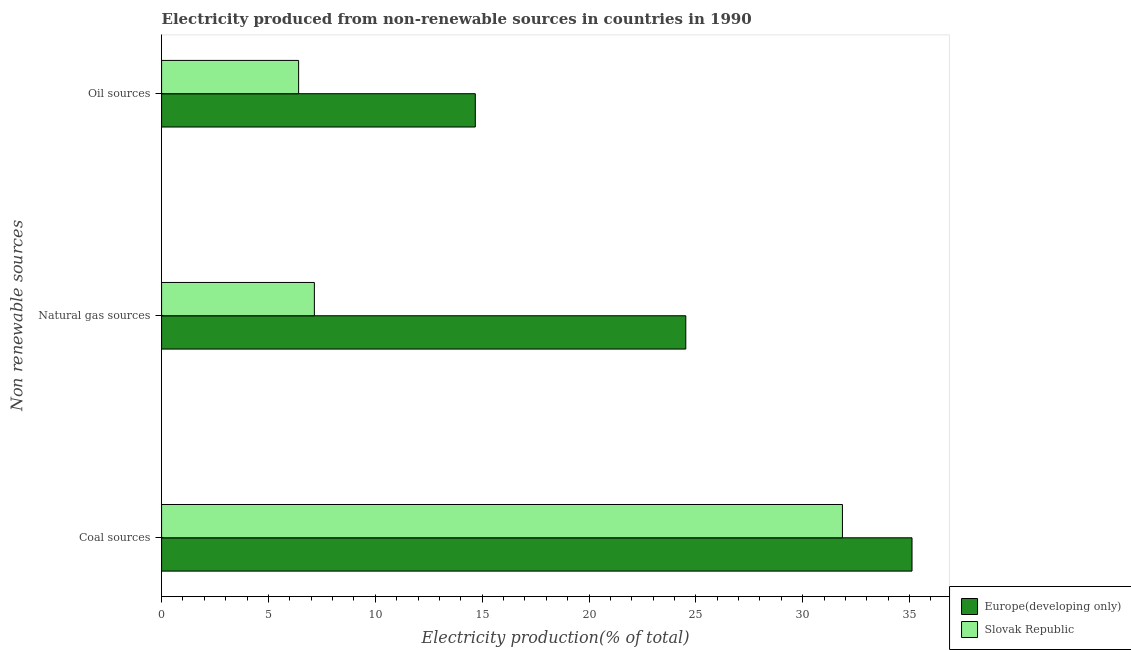How many groups of bars are there?
Offer a very short reply. 3. Are the number of bars per tick equal to the number of legend labels?
Your answer should be very brief. Yes. How many bars are there on the 2nd tick from the top?
Provide a short and direct response. 2. How many bars are there on the 3rd tick from the bottom?
Offer a very short reply. 2. What is the label of the 1st group of bars from the top?
Your response must be concise. Oil sources. What is the percentage of electricity produced by coal in Europe(developing only)?
Your answer should be very brief. 35.11. Across all countries, what is the maximum percentage of electricity produced by natural gas?
Ensure brevity in your answer.  24.53. Across all countries, what is the minimum percentage of electricity produced by coal?
Give a very brief answer. 31.86. In which country was the percentage of electricity produced by natural gas maximum?
Your answer should be compact. Europe(developing only). In which country was the percentage of electricity produced by oil sources minimum?
Provide a short and direct response. Slovak Republic. What is the total percentage of electricity produced by oil sources in the graph?
Ensure brevity in your answer.  21.09. What is the difference between the percentage of electricity produced by natural gas in Europe(developing only) and that in Slovak Republic?
Offer a terse response. 17.38. What is the difference between the percentage of electricity produced by oil sources in Slovak Republic and the percentage of electricity produced by coal in Europe(developing only)?
Your response must be concise. -28.7. What is the average percentage of electricity produced by oil sources per country?
Make the answer very short. 10.55. What is the difference between the percentage of electricity produced by oil sources and percentage of electricity produced by coal in Slovak Republic?
Offer a very short reply. -25.45. What is the ratio of the percentage of electricity produced by oil sources in Europe(developing only) to that in Slovak Republic?
Your response must be concise. 2.29. Is the percentage of electricity produced by natural gas in Slovak Republic less than that in Europe(developing only)?
Offer a very short reply. Yes. Is the difference between the percentage of electricity produced by coal in Europe(developing only) and Slovak Republic greater than the difference between the percentage of electricity produced by natural gas in Europe(developing only) and Slovak Republic?
Ensure brevity in your answer.  No. What is the difference between the highest and the second highest percentage of electricity produced by natural gas?
Make the answer very short. 17.38. What is the difference between the highest and the lowest percentage of electricity produced by coal?
Give a very brief answer. 3.26. In how many countries, is the percentage of electricity produced by coal greater than the average percentage of electricity produced by coal taken over all countries?
Ensure brevity in your answer.  1. What does the 2nd bar from the top in Coal sources represents?
Offer a terse response. Europe(developing only). What does the 1st bar from the bottom in Natural gas sources represents?
Keep it short and to the point. Europe(developing only). Is it the case that in every country, the sum of the percentage of electricity produced by coal and percentage of electricity produced by natural gas is greater than the percentage of electricity produced by oil sources?
Your answer should be very brief. Yes. Are all the bars in the graph horizontal?
Give a very brief answer. Yes. What is the difference between two consecutive major ticks on the X-axis?
Your answer should be very brief. 5. Are the values on the major ticks of X-axis written in scientific E-notation?
Your answer should be compact. No. Does the graph contain any zero values?
Provide a succinct answer. No. Does the graph contain grids?
Provide a short and direct response. No. Where does the legend appear in the graph?
Offer a terse response. Bottom right. How many legend labels are there?
Offer a terse response. 2. What is the title of the graph?
Give a very brief answer. Electricity produced from non-renewable sources in countries in 1990. Does "Andorra" appear as one of the legend labels in the graph?
Keep it short and to the point. No. What is the label or title of the Y-axis?
Your response must be concise. Non renewable sources. What is the Electricity production(% of total) in Europe(developing only) in Coal sources?
Offer a terse response. 35.11. What is the Electricity production(% of total) of Slovak Republic in Coal sources?
Provide a short and direct response. 31.86. What is the Electricity production(% of total) in Europe(developing only) in Natural gas sources?
Offer a very short reply. 24.53. What is the Electricity production(% of total) of Slovak Republic in Natural gas sources?
Give a very brief answer. 7.15. What is the Electricity production(% of total) in Europe(developing only) in Oil sources?
Ensure brevity in your answer.  14.68. What is the Electricity production(% of total) of Slovak Republic in Oil sources?
Provide a short and direct response. 6.41. Across all Non renewable sources, what is the maximum Electricity production(% of total) in Europe(developing only)?
Keep it short and to the point. 35.11. Across all Non renewable sources, what is the maximum Electricity production(% of total) in Slovak Republic?
Give a very brief answer. 31.86. Across all Non renewable sources, what is the minimum Electricity production(% of total) of Europe(developing only)?
Provide a short and direct response. 14.68. Across all Non renewable sources, what is the minimum Electricity production(% of total) in Slovak Republic?
Give a very brief answer. 6.41. What is the total Electricity production(% of total) of Europe(developing only) in the graph?
Your answer should be very brief. 74.32. What is the total Electricity production(% of total) of Slovak Republic in the graph?
Your answer should be compact. 45.42. What is the difference between the Electricity production(% of total) of Europe(developing only) in Coal sources and that in Natural gas sources?
Provide a succinct answer. 10.59. What is the difference between the Electricity production(% of total) in Slovak Republic in Coal sources and that in Natural gas sources?
Give a very brief answer. 24.71. What is the difference between the Electricity production(% of total) in Europe(developing only) in Coal sources and that in Oil sources?
Offer a terse response. 20.43. What is the difference between the Electricity production(% of total) in Slovak Republic in Coal sources and that in Oil sources?
Provide a succinct answer. 25.45. What is the difference between the Electricity production(% of total) in Europe(developing only) in Natural gas sources and that in Oil sources?
Your answer should be compact. 9.85. What is the difference between the Electricity production(% of total) in Slovak Republic in Natural gas sources and that in Oil sources?
Provide a short and direct response. 0.74. What is the difference between the Electricity production(% of total) in Europe(developing only) in Coal sources and the Electricity production(% of total) in Slovak Republic in Natural gas sources?
Your answer should be very brief. 27.96. What is the difference between the Electricity production(% of total) of Europe(developing only) in Coal sources and the Electricity production(% of total) of Slovak Republic in Oil sources?
Your answer should be very brief. 28.7. What is the difference between the Electricity production(% of total) in Europe(developing only) in Natural gas sources and the Electricity production(% of total) in Slovak Republic in Oil sources?
Give a very brief answer. 18.12. What is the average Electricity production(% of total) of Europe(developing only) per Non renewable sources?
Offer a terse response. 24.77. What is the average Electricity production(% of total) in Slovak Republic per Non renewable sources?
Provide a succinct answer. 15.14. What is the difference between the Electricity production(% of total) in Europe(developing only) and Electricity production(% of total) in Slovak Republic in Coal sources?
Keep it short and to the point. 3.26. What is the difference between the Electricity production(% of total) of Europe(developing only) and Electricity production(% of total) of Slovak Republic in Natural gas sources?
Provide a succinct answer. 17.38. What is the difference between the Electricity production(% of total) in Europe(developing only) and Electricity production(% of total) in Slovak Republic in Oil sources?
Your response must be concise. 8.27. What is the ratio of the Electricity production(% of total) of Europe(developing only) in Coal sources to that in Natural gas sources?
Make the answer very short. 1.43. What is the ratio of the Electricity production(% of total) in Slovak Republic in Coal sources to that in Natural gas sources?
Your answer should be compact. 4.46. What is the ratio of the Electricity production(% of total) of Europe(developing only) in Coal sources to that in Oil sources?
Your answer should be compact. 2.39. What is the ratio of the Electricity production(% of total) in Slovak Republic in Coal sources to that in Oil sources?
Offer a very short reply. 4.97. What is the ratio of the Electricity production(% of total) of Europe(developing only) in Natural gas sources to that in Oil sources?
Your answer should be compact. 1.67. What is the ratio of the Electricity production(% of total) in Slovak Republic in Natural gas sources to that in Oil sources?
Keep it short and to the point. 1.11. What is the difference between the highest and the second highest Electricity production(% of total) in Europe(developing only)?
Make the answer very short. 10.59. What is the difference between the highest and the second highest Electricity production(% of total) of Slovak Republic?
Offer a terse response. 24.71. What is the difference between the highest and the lowest Electricity production(% of total) of Europe(developing only)?
Give a very brief answer. 20.43. What is the difference between the highest and the lowest Electricity production(% of total) in Slovak Republic?
Offer a very short reply. 25.45. 